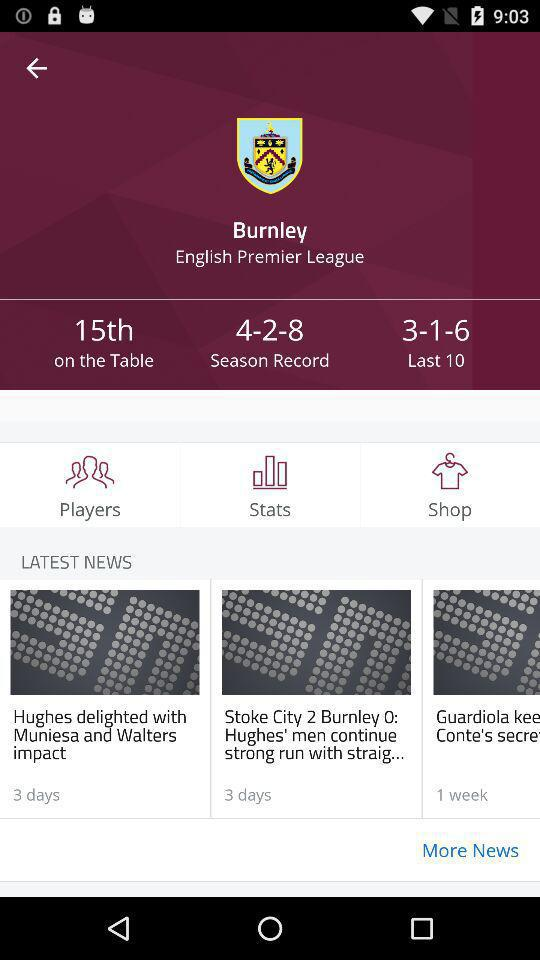What is the table number? The table number is 15. 